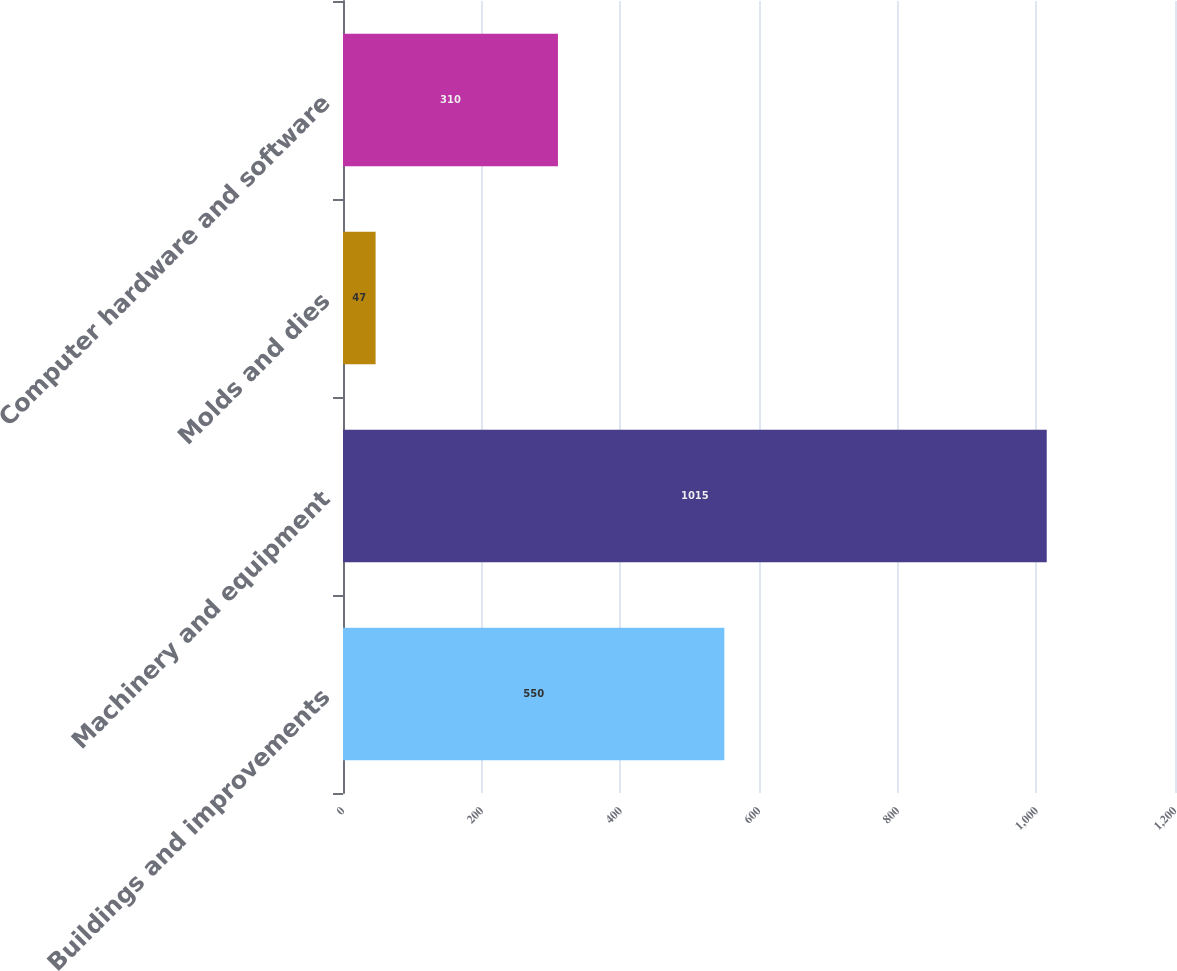<chart> <loc_0><loc_0><loc_500><loc_500><bar_chart><fcel>Buildings and improvements<fcel>Machinery and equipment<fcel>Molds and dies<fcel>Computer hardware and software<nl><fcel>550<fcel>1015<fcel>47<fcel>310<nl></chart> 